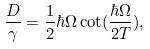<formula> <loc_0><loc_0><loc_500><loc_500>\frac { D } { \gamma } = \frac { 1 } { 2 } \hbar { \Omega } \cot ( \frac { \hbar { \Omega } } { 2 T } ) ,</formula> 